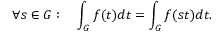Convert formula to latex. <formula><loc_0><loc_0><loc_500><loc_500>\forall s \in G \colon \quad \int _ { G } f ( t ) d t = \int _ { G } f ( s t ) d t .</formula> 